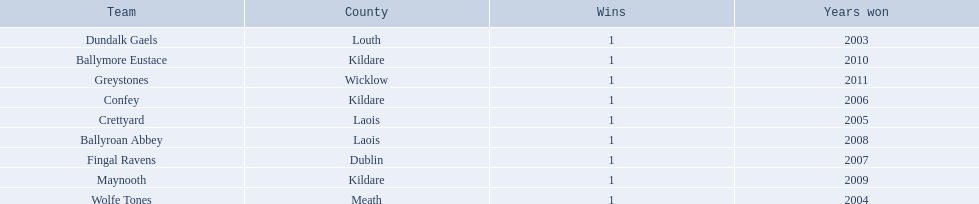What county is ballymore eustace from? Kildare. Besides convey, which other team is from the same county? Maynooth. Where is ballymore eustace from? Kildare. What teams other than ballymore eustace is from kildare? Maynooth, Confey. Between maynooth and confey, which won in 2009? Maynooth. 